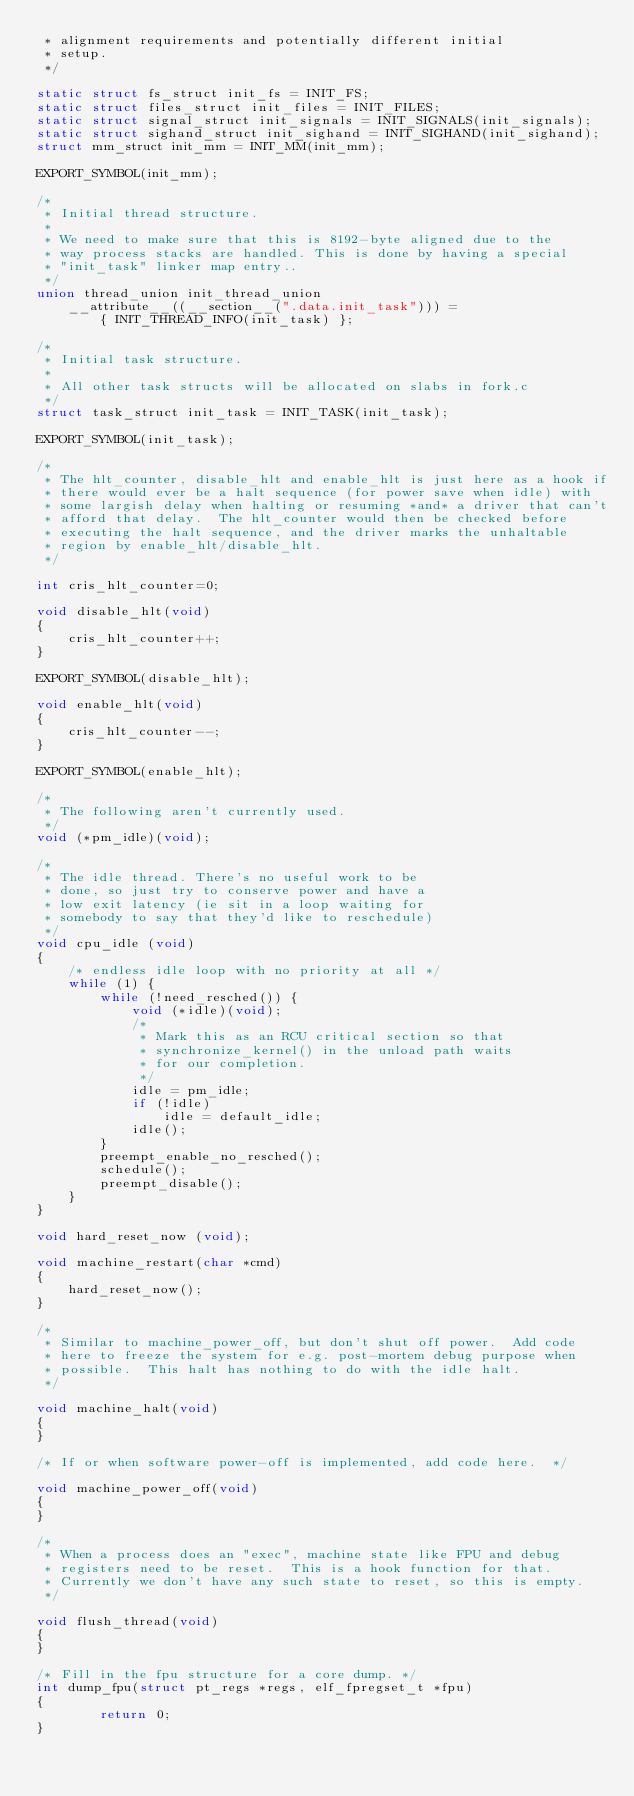Convert code to text. <code><loc_0><loc_0><loc_500><loc_500><_C_> * alignment requirements and potentially different initial
 * setup.
 */

static struct fs_struct init_fs = INIT_FS;
static struct files_struct init_files = INIT_FILES;
static struct signal_struct init_signals = INIT_SIGNALS(init_signals);
static struct sighand_struct init_sighand = INIT_SIGHAND(init_sighand);
struct mm_struct init_mm = INIT_MM(init_mm);

EXPORT_SYMBOL(init_mm);

/*
 * Initial thread structure.
 *
 * We need to make sure that this is 8192-byte aligned due to the
 * way process stacks are handled. This is done by having a special
 * "init_task" linker map entry..
 */
union thread_union init_thread_union 
	__attribute__((__section__(".data.init_task"))) =
		{ INIT_THREAD_INFO(init_task) };

/*
 * Initial task structure.
 *
 * All other task structs will be allocated on slabs in fork.c
 */
struct task_struct init_task = INIT_TASK(init_task);

EXPORT_SYMBOL(init_task);

/*
 * The hlt_counter, disable_hlt and enable_hlt is just here as a hook if
 * there would ever be a halt sequence (for power save when idle) with
 * some largish delay when halting or resuming *and* a driver that can't
 * afford that delay.  The hlt_counter would then be checked before
 * executing the halt sequence, and the driver marks the unhaltable
 * region by enable_hlt/disable_hlt.
 */

int cris_hlt_counter=0;

void disable_hlt(void)
{
	cris_hlt_counter++;
}

EXPORT_SYMBOL(disable_hlt);

void enable_hlt(void)
{
	cris_hlt_counter--;
}

EXPORT_SYMBOL(enable_hlt);
 
/*
 * The following aren't currently used.
 */
void (*pm_idle)(void);

/*
 * The idle thread. There's no useful work to be
 * done, so just try to conserve power and have a
 * low exit latency (ie sit in a loop waiting for
 * somebody to say that they'd like to reschedule)
 */
void cpu_idle (void)
{
	/* endless idle loop with no priority at all */
	while (1) {
		while (!need_resched()) {
			void (*idle)(void);
			/*
			 * Mark this as an RCU critical section so that
			 * synchronize_kernel() in the unload path waits
			 * for our completion.
			 */
			idle = pm_idle;
			if (!idle)
				idle = default_idle;
			idle();
		}
		preempt_enable_no_resched();
		schedule();
		preempt_disable();
	}
}

void hard_reset_now (void);

void machine_restart(char *cmd)
{
	hard_reset_now();
}

/*
 * Similar to machine_power_off, but don't shut off power.  Add code
 * here to freeze the system for e.g. post-mortem debug purpose when
 * possible.  This halt has nothing to do with the idle halt.
 */

void machine_halt(void)
{
}

/* If or when software power-off is implemented, add code here.  */

void machine_power_off(void)
{
}

/*
 * When a process does an "exec", machine state like FPU and debug
 * registers need to be reset.  This is a hook function for that.
 * Currently we don't have any such state to reset, so this is empty.
 */

void flush_thread(void)
{
}

/* Fill in the fpu structure for a core dump. */
int dump_fpu(struct pt_regs *regs, elf_fpregset_t *fpu)
{
        return 0;
}
</code> 